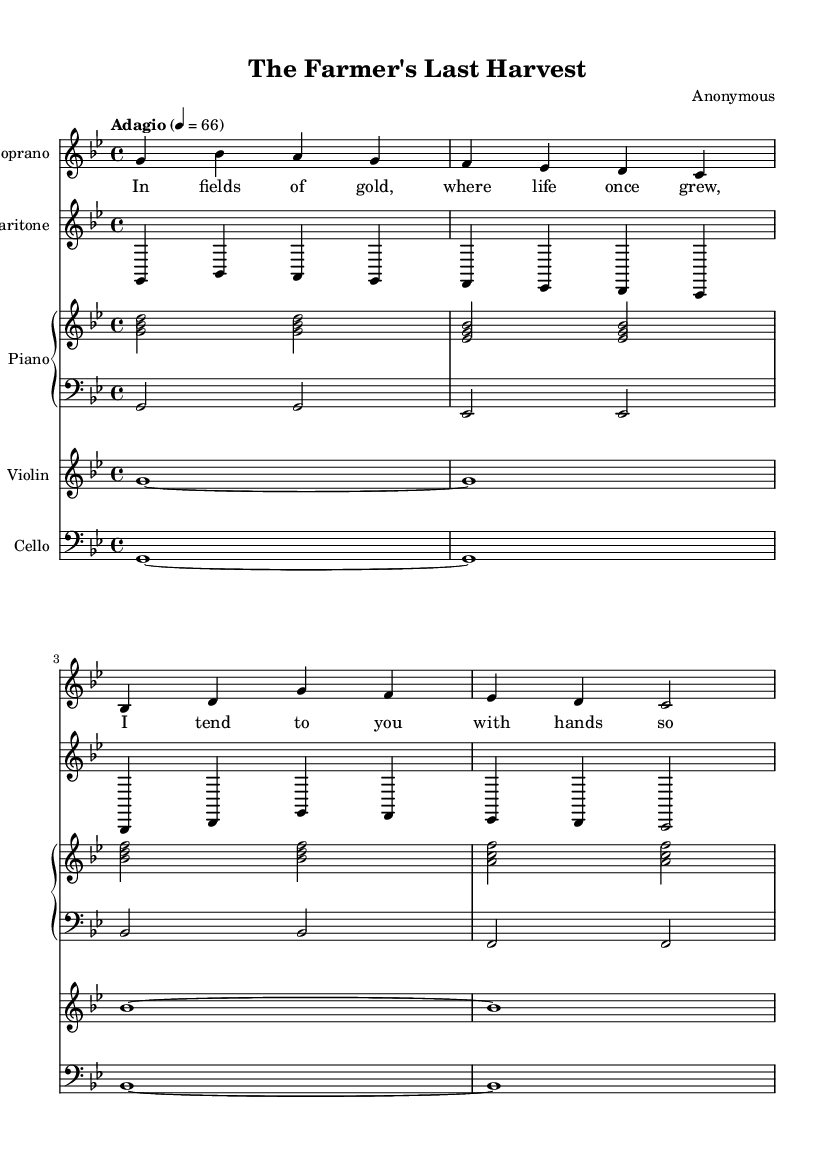What is the key signature of this music? The key signature is G minor, which features two flats: B flat and E flat. This can be determined by analyzing the key signature indication at the beginning of the sheet music.
Answer: G minor What is the time signature of this music? The time signature is 4/4, as indicated in the top left corner of the sheet music, which denotes four beats per measure with a quarter note receiving one beat.
Answer: 4/4 What is the tempo marking for this piece? The tempo marking is "Adagio," which suggests a slow tempo. This can be found next to the tempo indication at the start of the score.
Answer: Adagio How many instruments are featured in this score? The score features five instruments: Soprano, Baritone, Piano, Violin, and Cello. This can be seen from the different staves labeled at the beginning of the music.
Answer: Five What type of opera does this piece represent? This piece represents a tragic opera as it explores themes of human suffering, specifically the relationship between a dying farmer and his caregiver. The emotional context provided by the lyrics supports this classification.
Answer: Tragic opera Which voice part has the melody in the beginning? The Soprano has the melody in the beginning, as it is presented prominently in the upper staff with lyrics attached, contrasting with the supporting Baritone line below it.
Answer: Soprano 